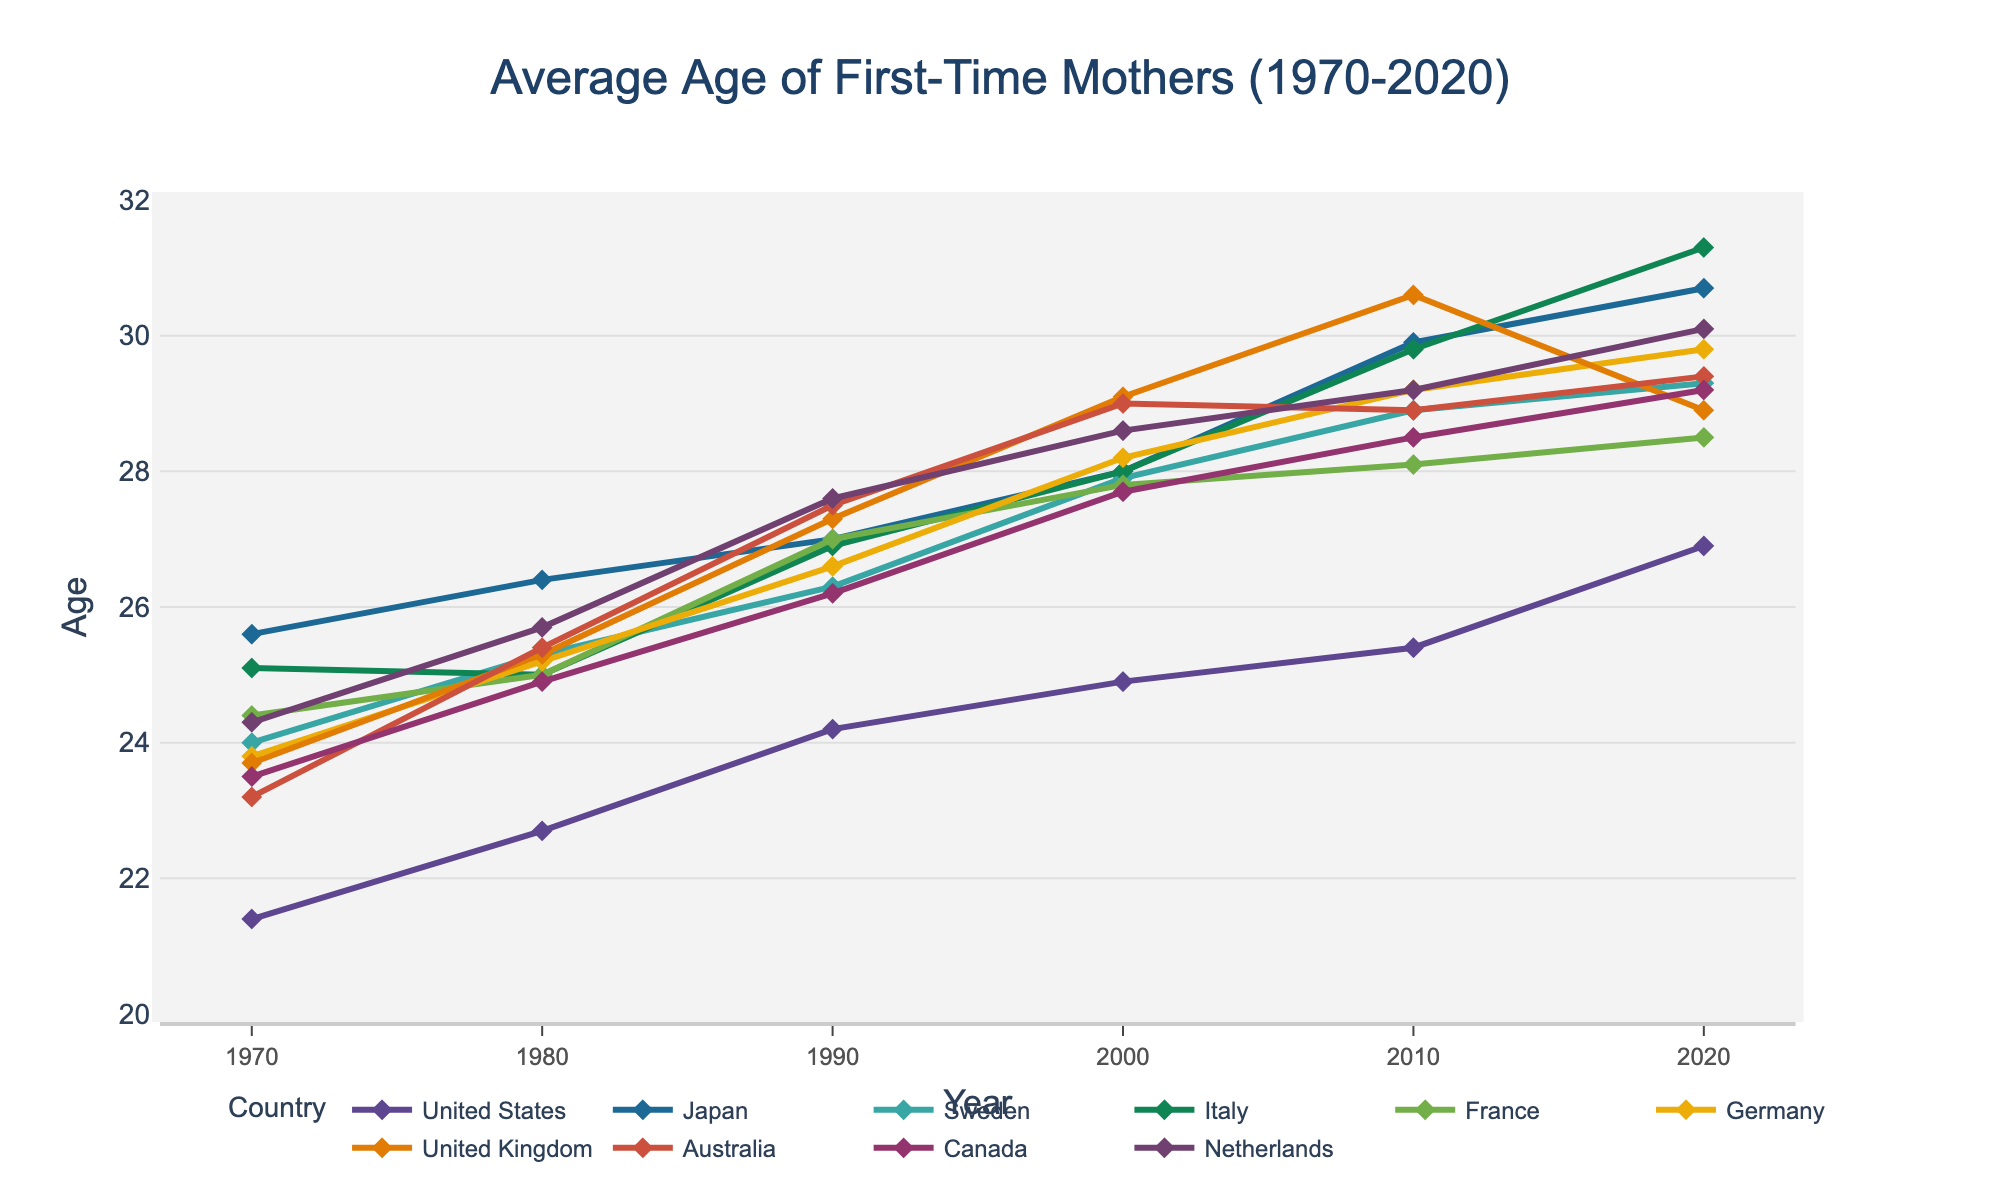what's the trend of the average age of first-time mothers in United States from 1970 to 2020? By observing the line representing the United States, it slopes upwards continuously from 1970 to 2020, indicating that the average age of first-time mothers has been increasing consistently over this period.
Answer: Increasing Which country had the highest average age of first-time mothers in 2020? By looking at the line plots for all countries in the year 2020, Italy's line sits highest above the other countries at 31.3 years.
Answer: Italy How much did the average age of first-time mothers increase in Japan from 1970 to 2020? The increase can be calculated by subtracting the 1970 value from the 2020 value for Japan: 30.7 - 25.6 = 5.1 years.
Answer: 5.1 years Which two countries had a similar average age of first-time mothers in 1980? By examining the plotted points for 1980, the average ages for France and Italy in 1980 were both around 25.0 years.
Answer: France and Italy Between 2010 and 2020, which country saw the smallest increase in the average age of first-time mothers? By comparing the increments for each country between 2010 and 2020, the United Kingdom saw a decrease: 30.6 (2010) to 28.9 (2020). The smallest positive increase is Sweden with an increase of 0.4 years from 28.9 to 29.3.
Answer: Sweden Between 1970 and 2020, which country experienced the greatest increase in the average age of first-time mothers? This increase can be calculated by subtracting 1970 values from 2020 values for each country and finding the maximum difference. Italy shows the greatest increase: 31.3 - 25.1 = 6.2 years.
Answer: Italy What is the difference in the average age of first-time mothers between Canada and Germany in 1990? By comparing the values in 1990, Germany had 26.6 and Canada had 26.2. The difference is 26.6 - 26.2 = 0.4 years.
Answer: 0.4 years In which decade did the United Kingdom experience the greatest change in the average age of first-time mothers? By observing the United Kingdom's line, the steepest change occurs between 1980 (25.3) and 1990 (27.3), indicating a change of 2.0 years in the 1980s.
Answer: 1980s 